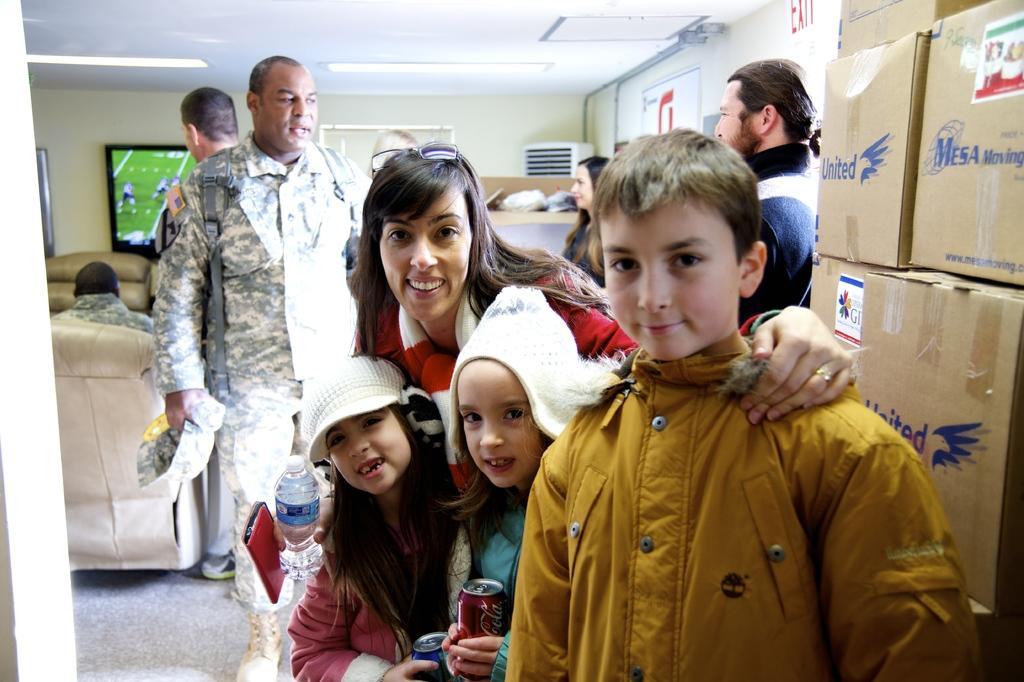Please provide a concise description of this image. This image is clicked inside a room. There are some persons in the middle. There are sofas on the left side. There is a tv on the left side. Some are wearing military dresses. There are boxes on the right side. There are lights at the top. 